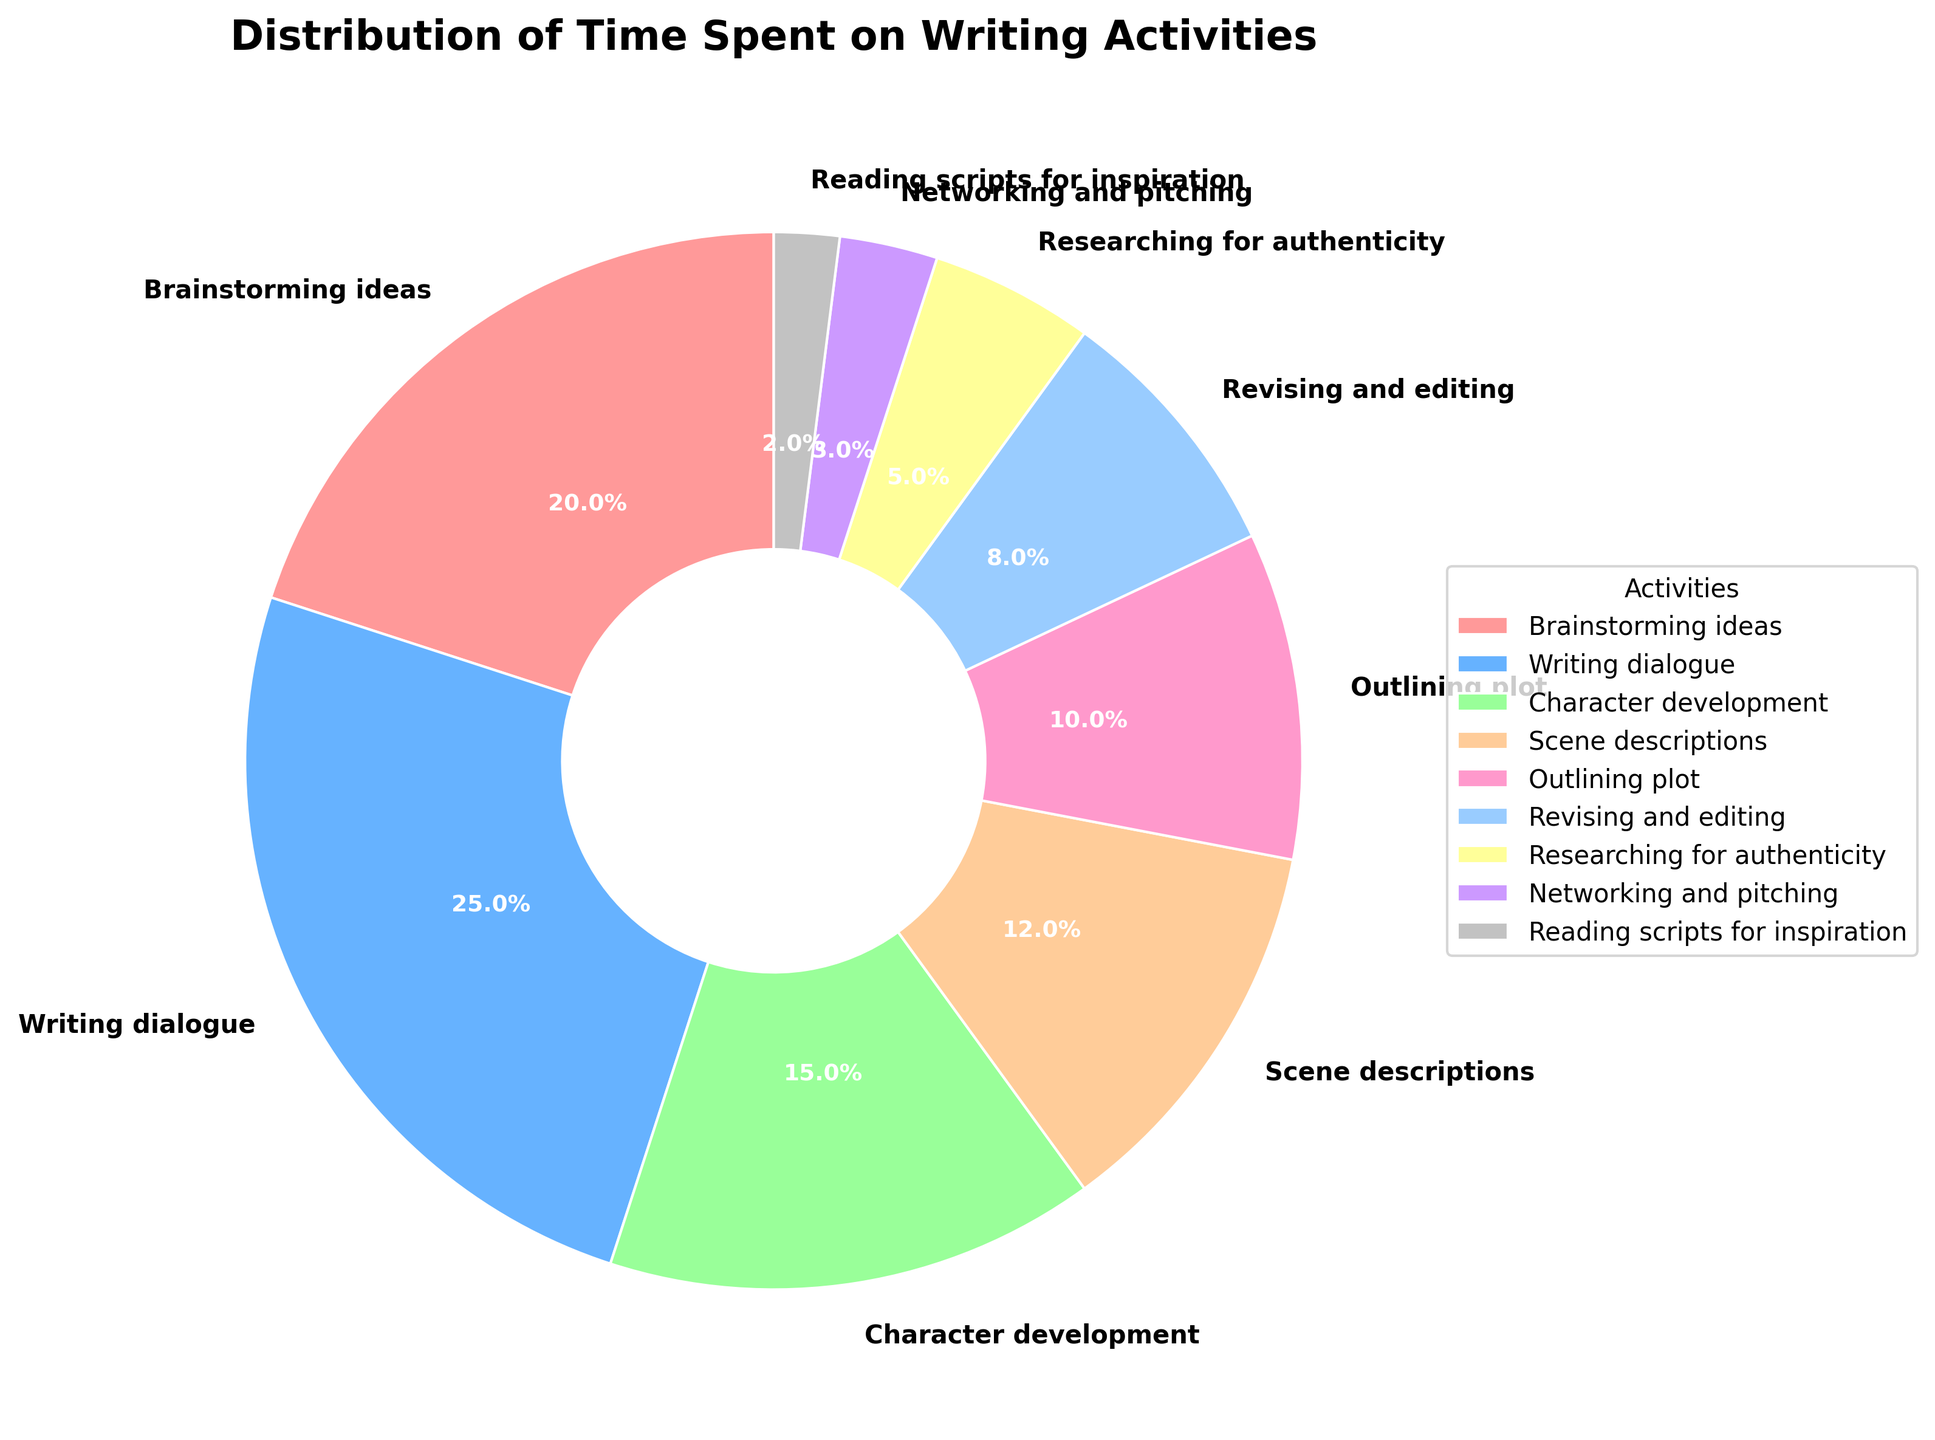what percentage of time is spent on brainstorming ideas and writing dialogue combined? First, look at the portions for "Brainstorming ideas" (20%) and "Writing dialogue" (25%). Add these percentages together: 20% + 25% = 45%.
Answer: 45% Which activity takes up more time, character development or scene descriptions? Refer to the segments for "Character development" (15%) and "Scene descriptions" (12%). Since 15% is more than 12%, "Character development" takes more time.
Answer: Character development What is the difference in time percentage between outlining plot and revising and editing? Look at the segments for "Outlining plot" (10%) and "Revising and editing" (8%). Subtract the smaller percentage from the larger one: 10% - 8% = 2%.
Answer: 2% Which activities are represented by the top three largest segments? Observe which segments are the largest by percentage: "Writing dialogue" (25%), "Brainstorming ideas" (20%), and "Character development" (15%) are the top three.
Answer: Writing dialogue, Brainstorming ideas, Character development How many activities take up less than 10% of the time each? Identify the segments with less than 10%: "Revising and editing" (8%), "Researching for authenticity" (5%), "Networking and pitching" (3%), and "Reading scripts for inspiration" (2%). Count these activities: 4.
Answer: 4 What is the total percentage of time spent on brainstorming ideas, writing dialogue, and revising and editing? Look at the segments for "Brainstorming ideas" (20%), "Writing dialogue" (25%), and "Revising and editing" (8%). Sum these percentages: 20% + 25% + 8% = 53%.
Answer: 53% Which activity accounts for the smallest portion of time? Find the segment with the smallest percentage: "Reading scripts for inspiration" (2%) is the smallest portion.
Answer: Reading scripts for inspiration Compare the time spent on character development and outlining plot. How much more time is spent on character development? Look at "Character development" (15%) and "Outlining plot" (10%). Subtract the smaller from the larger: 15% - 10% = 5%.
Answer: 5% Which color represents the activity with the second highest time allocation? Identify the color corresponding to the "Writing dialogue" segment (25%), which is second highest after "Brainstorming ideas" (20%). The "Writing dialogue" segment is blue.
Answer: Blue What percentage of time is spent on activities related to structuring (outlining plot and scene descriptions)? Look at the segments for "Outlining plot" (10%) and "Scene descriptions" (12%). Add these percentages together: 10% + 12% = 22%.
Answer: 22% 